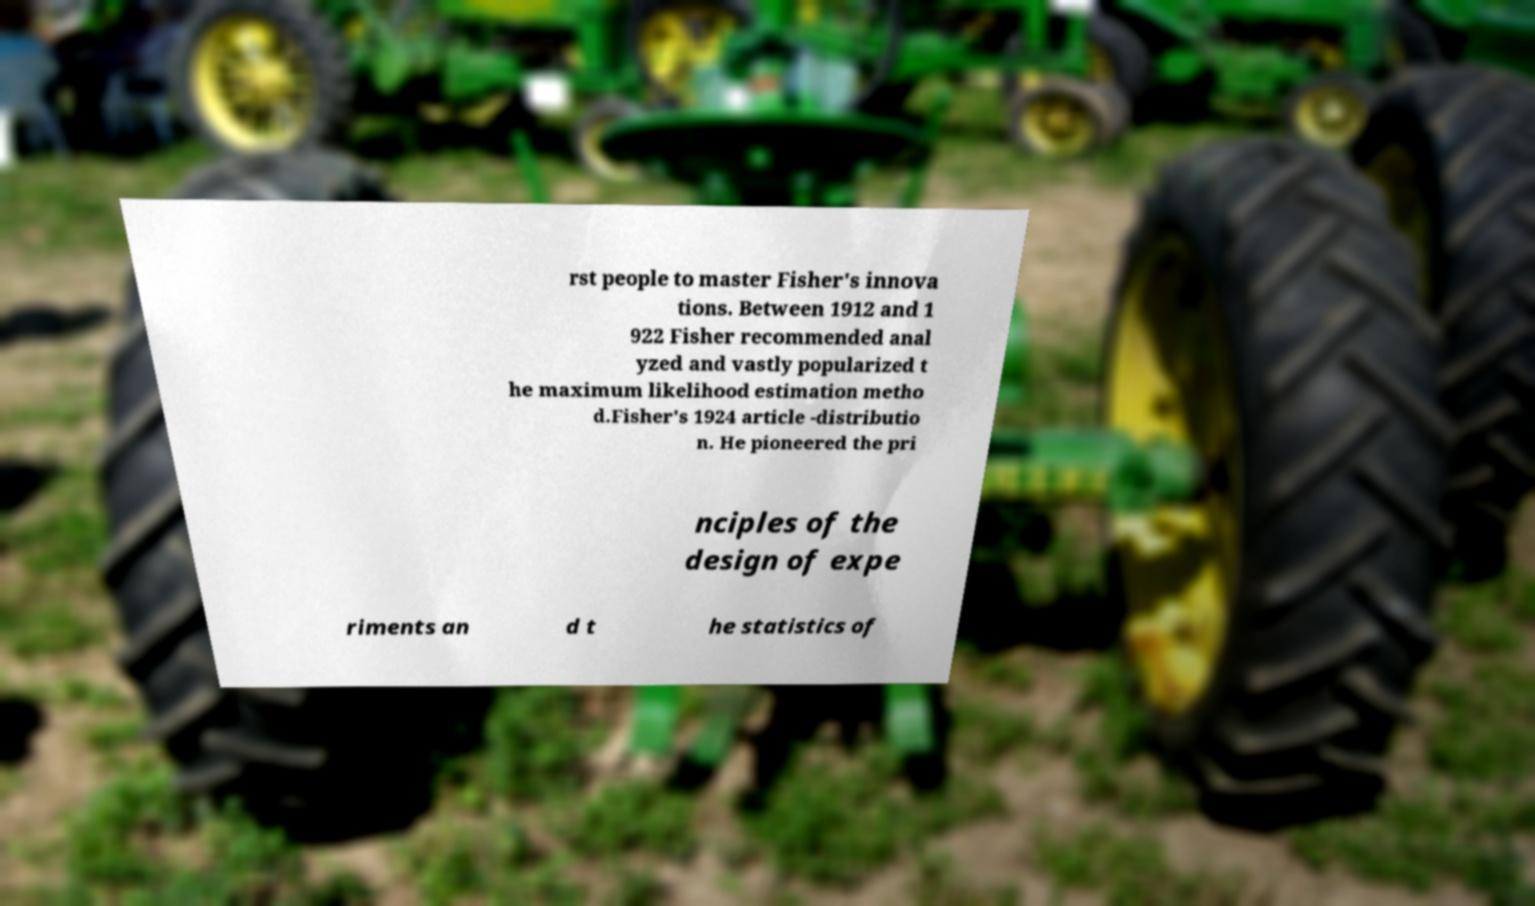Please identify and transcribe the text found in this image. rst people to master Fisher's innova tions. Between 1912 and 1 922 Fisher recommended anal yzed and vastly popularized t he maximum likelihood estimation metho d.Fisher's 1924 article -distributio n. He pioneered the pri nciples of the design of expe riments an d t he statistics of 